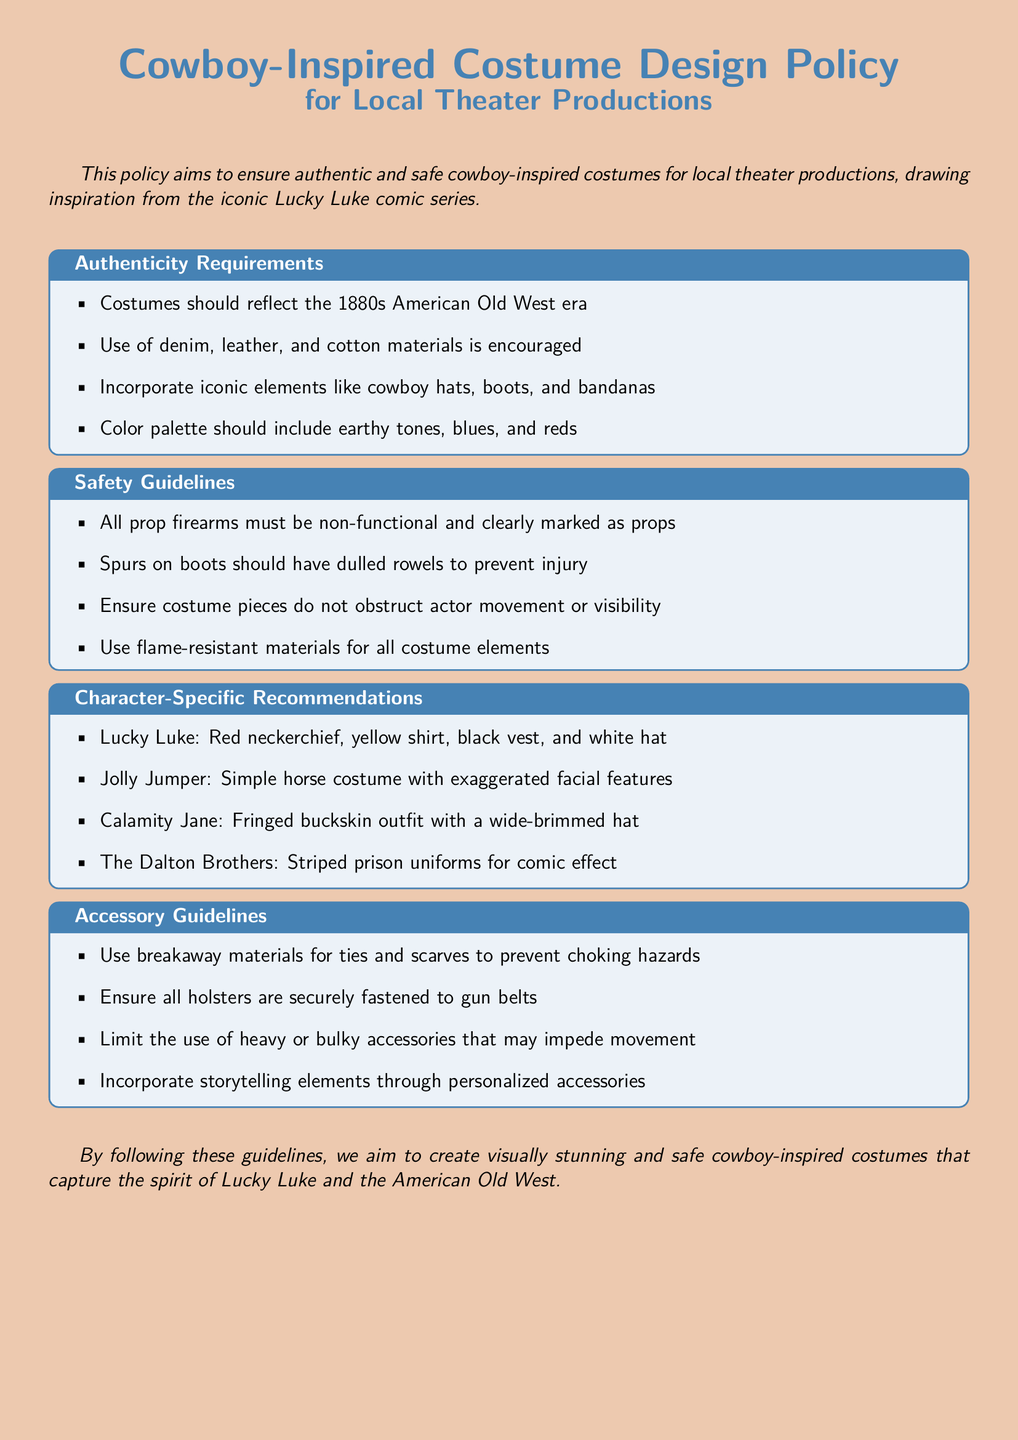What era should costumes reflect? The document specifies that costumes should reflect the 1880s American Old West era.
Answer: 1880s American Old West What materials are encouraged for costumes? The policy encourages the use of denim, leather, and cotton materials for authenticity.
Answer: Denim, leather, and cotton How should spurs be designed on boots? The safety guideline states that spurs on boots should have dulled rowels to prevent injury.
Answer: Dull rowels What color palette should be included in costumes? The color palette for costumes should include earthy tones, blues, and reds.
Answer: Earthy tones, blues, and reds What is Lucky Luke's iconic accessory? Lucky Luke is known for his red neckerchief as an essential part of his costume.
Answer: Red neckerchief What type of costume is recommended for Jolly Jumper? The document recommends a simple horse costume with exaggerated facial features for Jolly Jumper.
Answer: Simple horse costume What should be used for ties and scarves to prevent choking hazards? The guideline specifies to use breakaway materials for ties and scarves.
Answer: Breakaway materials What costume element must not obstruct actor visibility? The safety guidelines emphasize that costume pieces must not obstruct actor movement or visibility.
Answer: Costume pieces What is the purpose of this policy document? The purpose of the policy is to ensure authentic and safe cowboy-inspired costumes for local theater productions.
Answer: Ensure authentic and safe costumes 